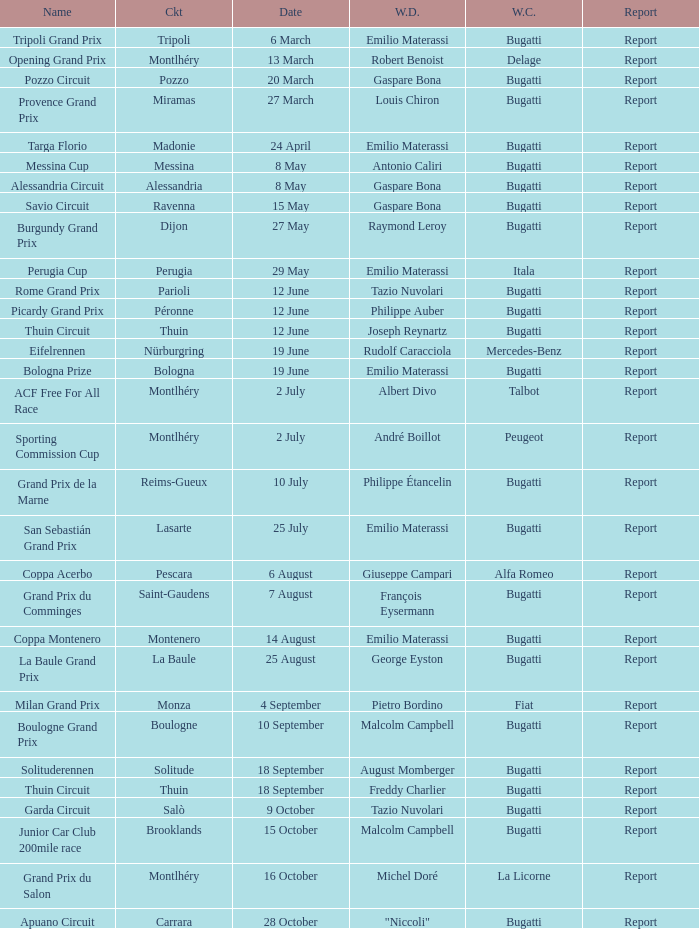Who was the winning constructor of the Grand Prix Du Salon ? La Licorne. 